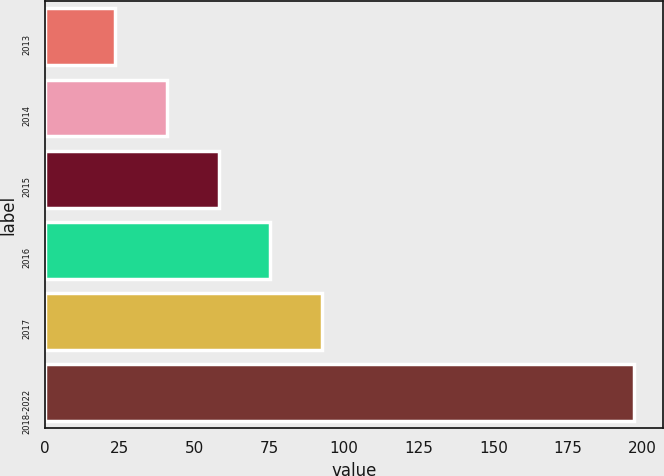Convert chart. <chart><loc_0><loc_0><loc_500><loc_500><bar_chart><fcel>2013<fcel>2014<fcel>2015<fcel>2016<fcel>2017<fcel>2018-2022<nl><fcel>23.4<fcel>40.75<fcel>58.1<fcel>75.45<fcel>92.8<fcel>196.9<nl></chart> 